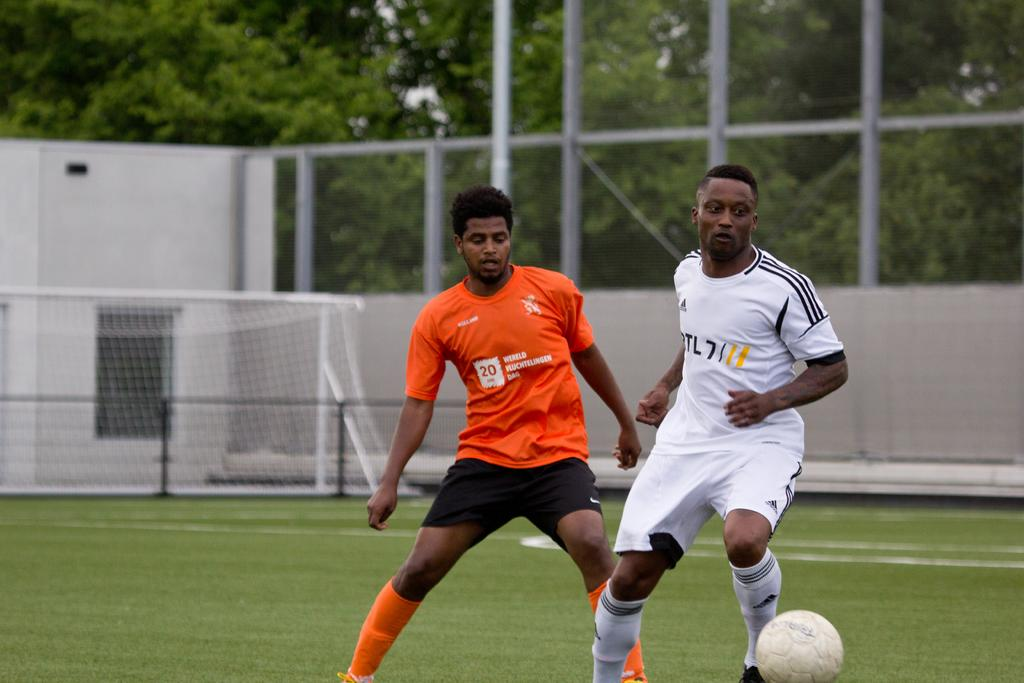How many players are involved in the game in the image? There are two players in the image. What sport are the players engaged in? The players are playing football. Where is the football game taking place? The football game is taking place on a ground. What is the main objective of the game? The main objective of the game is to score goals, as indicated by the presence of a goal post in the image. What can be seen in the background of the image? There is a fence and trees in the image. What type of word is being used by the players during the game in the image? There is no indication in the image that the players are using any specific words during the game. Can you see a scarecrow in the image? No, there is no scarecrow present in the image. 